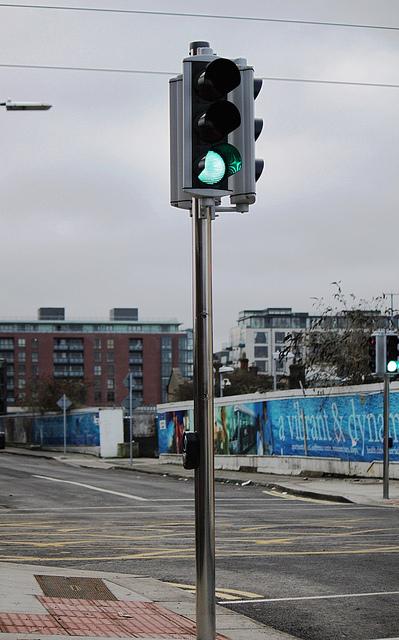What are on top of the red brick building?
Be succinct. Air conditioners. Is the color green in the scene?
Answer briefly. Yes. How is the weather in the scene?
Short answer required. Cloudy. 